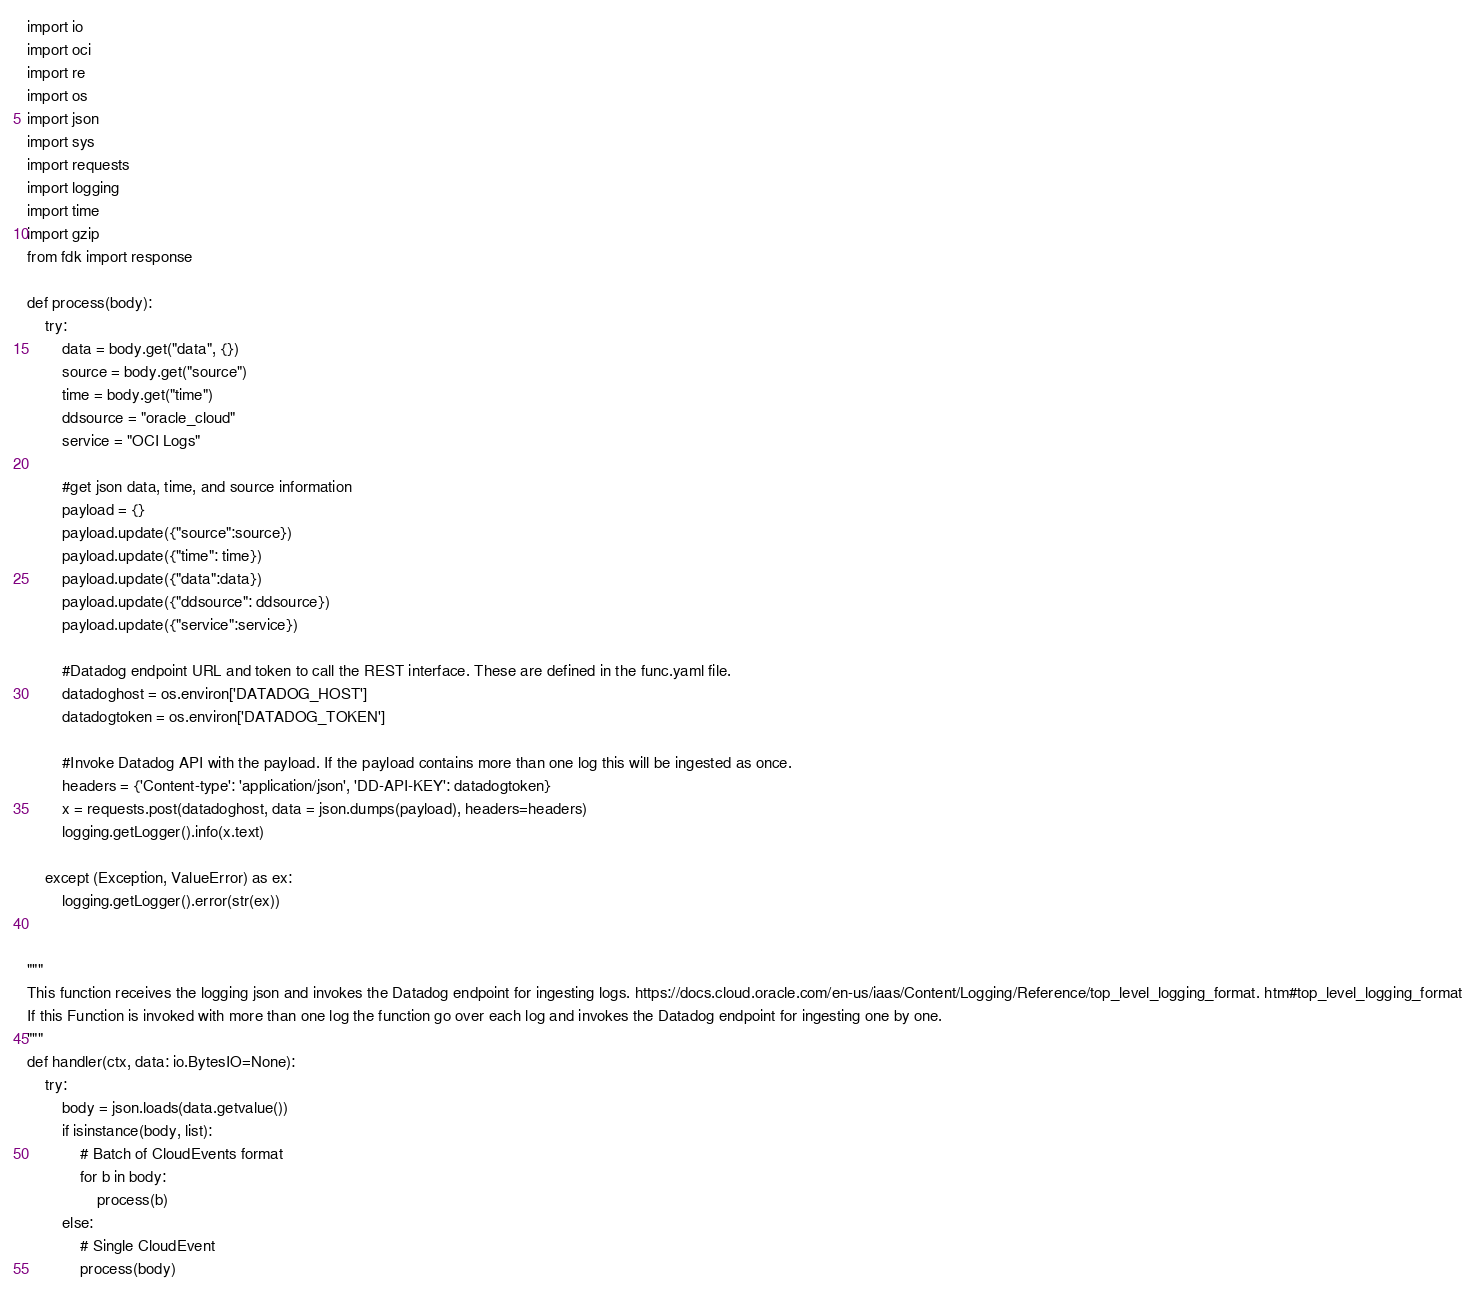<code> <loc_0><loc_0><loc_500><loc_500><_Python_>import io
import oci
import re
import os
import json
import sys
import requests
import logging
import time
import gzip
from fdk import response

def process(body):
    try:
        data = body.get("data", {}) 
        source = body.get("source") 
        time = body.get("time")
        ddsource = "oracle_cloud"
        service = "OCI Logs"

        #get json data, time, and source information
        payload = {}
        payload.update({"source":source}) 
        payload.update({"time": time}) 
        payload.update({"data":data})
        payload.update({"ddsource": ddsource}) 
        payload.update({"service":service})

        #Datadog endpoint URL and token to call the REST interface. These are defined in the func.yaml file. 
        datadoghost = os.environ['DATADOG_HOST']
        datadogtoken = os.environ['DATADOG_TOKEN']

        #Invoke Datadog API with the payload. If the payload contains more than one log this will be ingested as once. 
        headers = {'Content-type': 'application/json', 'DD-API-KEY': datadogtoken}
        x = requests.post(datadoghost, data = json.dumps(payload), headers=headers) 
        logging.getLogger().info(x.text)

    except (Exception, ValueError) as ex:
        logging.getLogger().error(str(ex))


"""
This function receives the logging json and invokes the Datadog endpoint for ingesting logs. https://docs.cloud.oracle.com/en-us/iaas/Content/Logging/Reference/top_level_logging_format. htm#top_level_logging_format
If this Function is invoked with more than one log the function go over each log and invokes the Datadog endpoint for ingesting one by one.
"""
def handler(ctx, data: io.BytesIO=None):
    try:
        body = json.loads(data.getvalue())
        if isinstance(body, list):
            # Batch of CloudEvents format
            for b in body:
                process(b)
        else:
            # Single CloudEvent
            process(body)</code> 